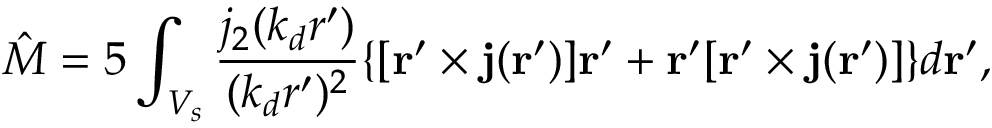Convert formula to latex. <formula><loc_0><loc_0><loc_500><loc_500>{ \hat { M } } = { 5 } \int _ { V _ { s } } \frac { j _ { 2 } ( k _ { d } r ^ { \prime } ) } { ( k _ { d } r ^ { \prime } ) ^ { 2 } } \{ [ { r } ^ { \prime } \times { j } ( { r } ^ { \prime } ) ] { r } ^ { \prime } + { r } ^ { \prime } [ { r } ^ { \prime } \times { j } ( { r } ^ { \prime } ) ] \} d { r } ^ { \prime } ,</formula> 